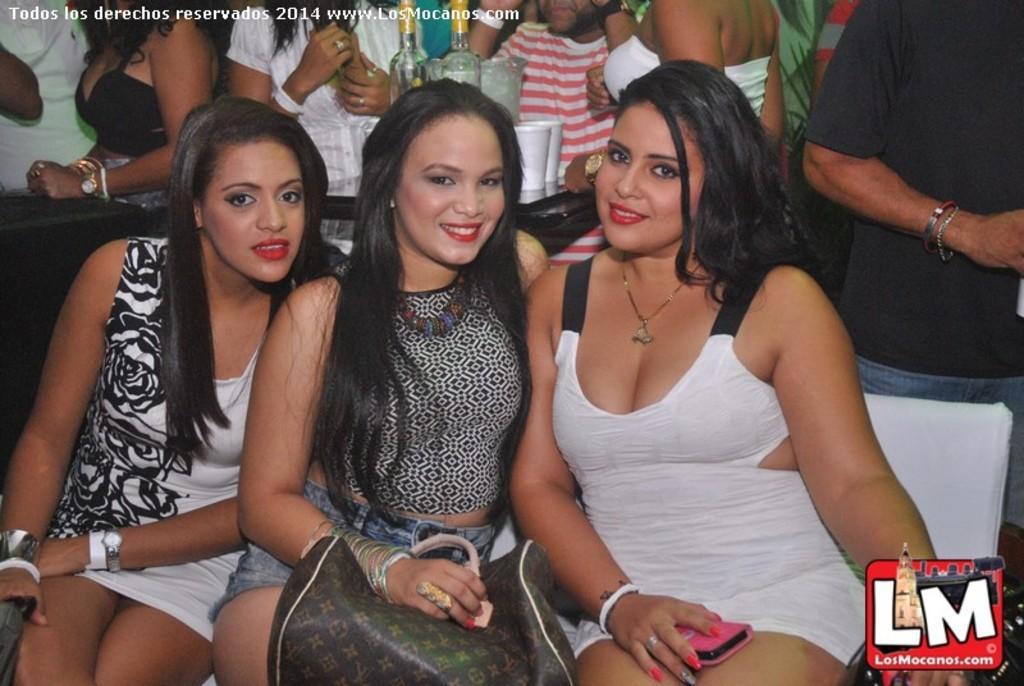How would you summarize this image in a sentence or two? In this image, in the middle, we can see three women are sitting on the chair. In the background, we can see a group of people and a table, on that table, we can see some bottles and a glass. 